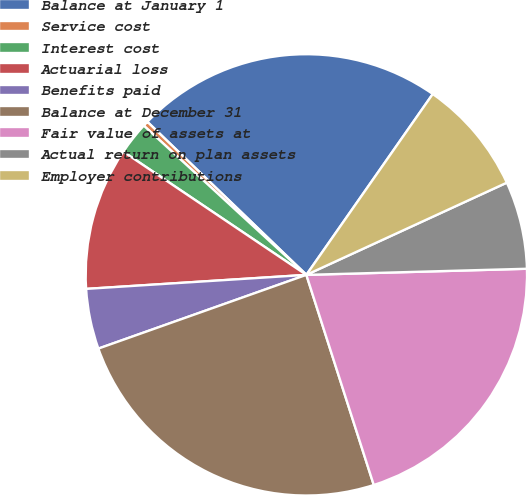Convert chart to OTSL. <chart><loc_0><loc_0><loc_500><loc_500><pie_chart><fcel>Balance at January 1<fcel>Service cost<fcel>Interest cost<fcel>Actuarial loss<fcel>Benefits paid<fcel>Balance at December 31<fcel>Fair value of assets at<fcel>Actual return on plan assets<fcel>Employer contributions<nl><fcel>22.51%<fcel>0.38%<fcel>2.39%<fcel>10.44%<fcel>4.41%<fcel>24.52%<fcel>20.5%<fcel>6.42%<fcel>8.43%<nl></chart> 